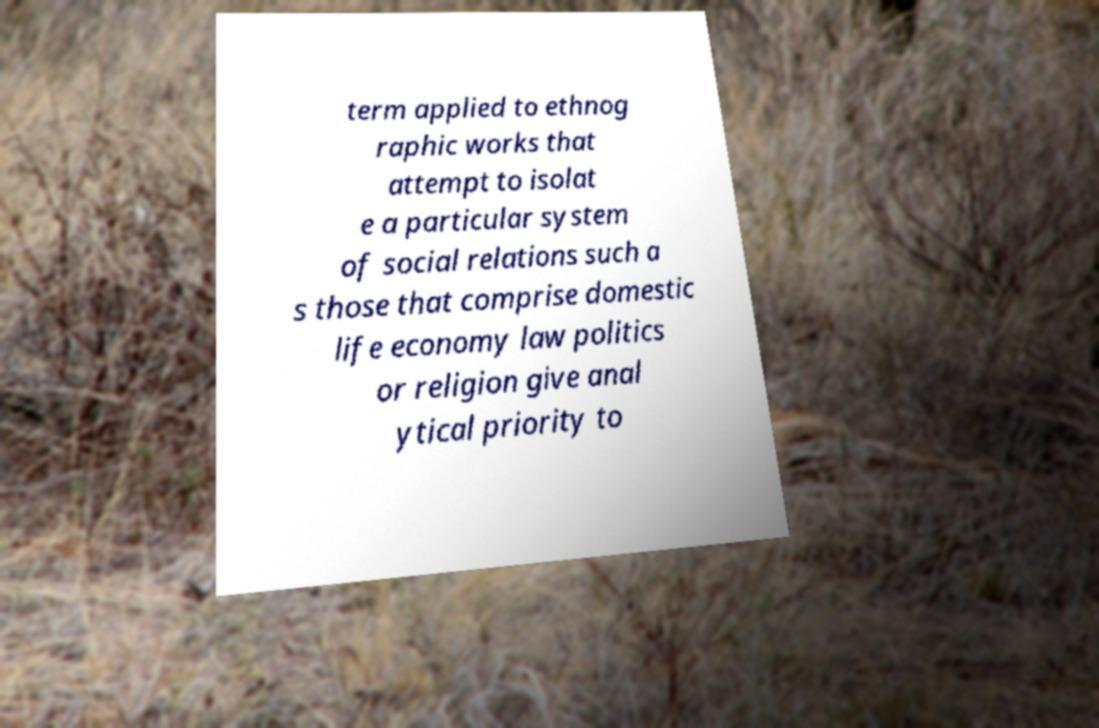Can you read and provide the text displayed in the image?This photo seems to have some interesting text. Can you extract and type it out for me? term applied to ethnog raphic works that attempt to isolat e a particular system of social relations such a s those that comprise domestic life economy law politics or religion give anal ytical priority to 